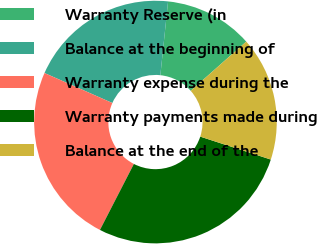Convert chart. <chart><loc_0><loc_0><loc_500><loc_500><pie_chart><fcel>Warranty Reserve (in<fcel>Balance at the beginning of<fcel>Warranty expense during the<fcel>Warranty payments made during<fcel>Balance at the end of the<nl><fcel>11.8%<fcel>20.04%<fcel>24.06%<fcel>27.56%<fcel>16.54%<nl></chart> 